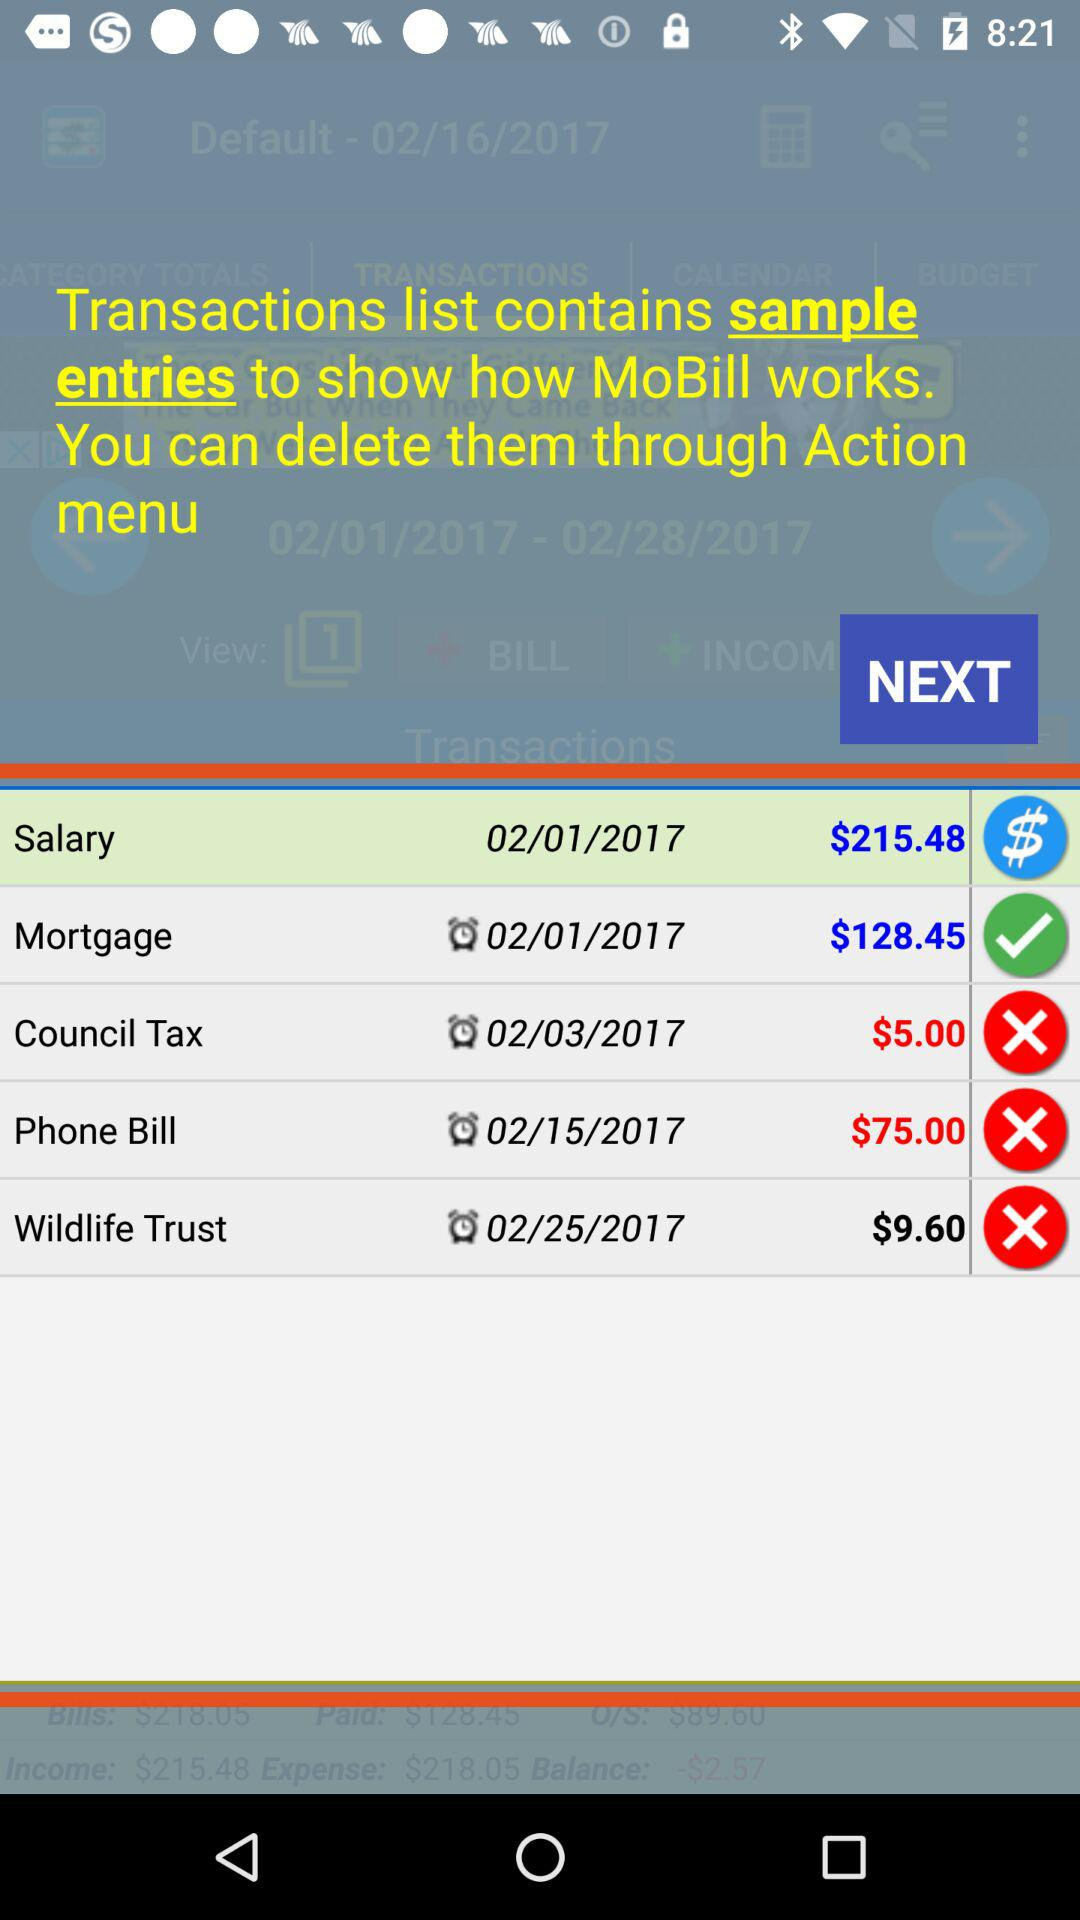On which date was the phone bill updated? The phone bill was updated on February 15, 2017. 